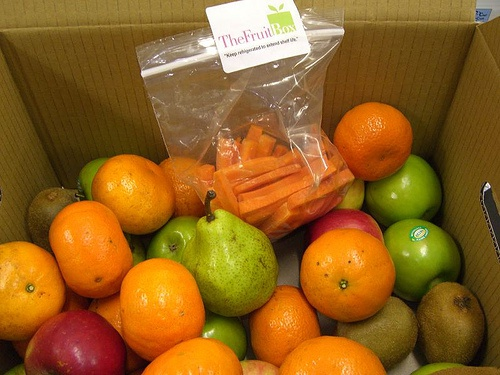Describe the objects in this image and their specific colors. I can see carrot in olive, red, brown, maroon, and orange tones, orange in olive, orange, brown, and maroon tones, orange in olive, orange, red, and brown tones, orange in olive, red, orange, and maroon tones, and orange in olive, orange, red, and maroon tones in this image. 